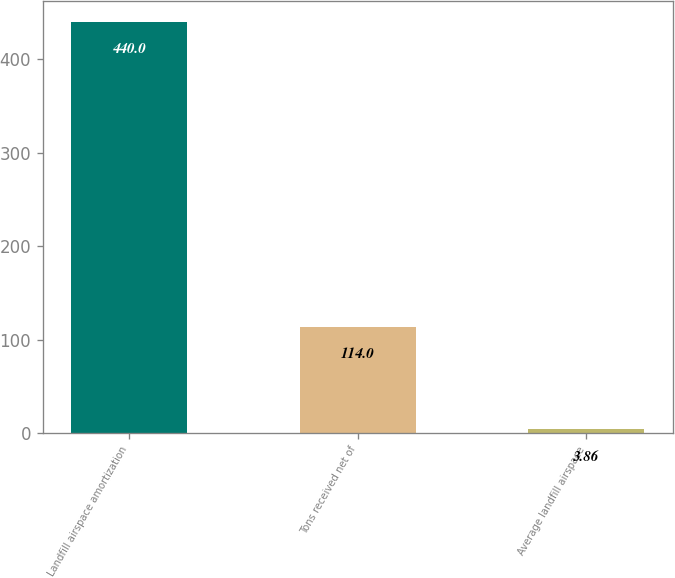<chart> <loc_0><loc_0><loc_500><loc_500><bar_chart><fcel>Landfill airspace amortization<fcel>Tons received net of<fcel>Average landfill airspace<nl><fcel>440<fcel>114<fcel>3.86<nl></chart> 